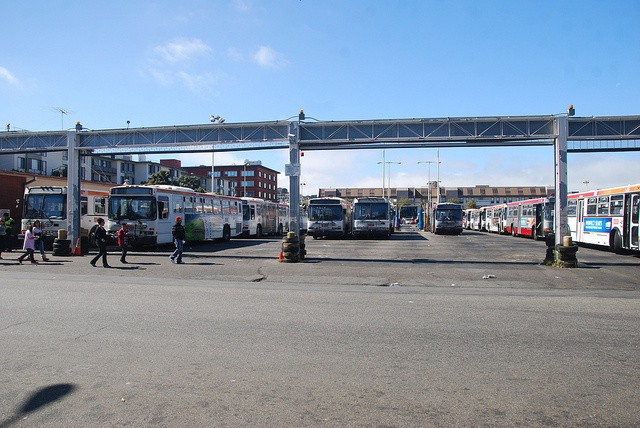Describe the objects in this image and their specific colors. I can see bus in lightblue, black, gray, and blue tones, bus in lightblue, white, black, gray, and darkgray tones, bus in lightblue, black, gray, darkgray, and blue tones, bus in lightblue, black, darkgray, gray, and lightgray tones, and bus in lightblue, black, navy, gray, and darkblue tones in this image. 